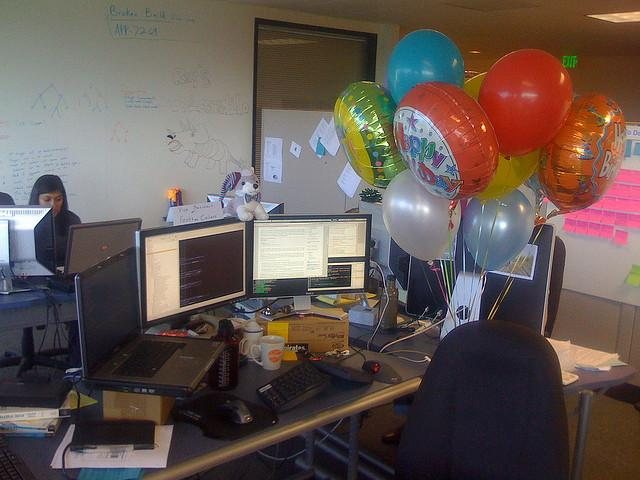What sort of wax item might be on a dessert enjoyed by the person sitting by the balloons today?

Choices:
A) waxed nails
B) joke teeth
C) moon
D) birthday candle birthday candle 